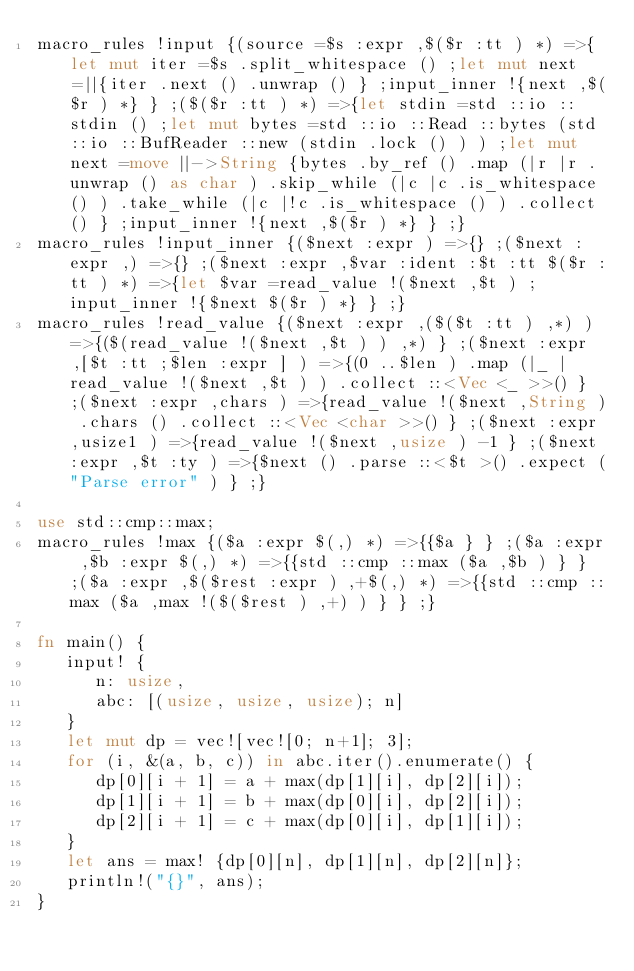Convert code to text. <code><loc_0><loc_0><loc_500><loc_500><_Rust_>macro_rules !input {(source =$s :expr ,$($r :tt ) *) =>{let mut iter =$s .split_whitespace () ;let mut next =||{iter .next () .unwrap () } ;input_inner !{next ,$($r ) *} } ;($($r :tt ) *) =>{let stdin =std ::io ::stdin () ;let mut bytes =std ::io ::Read ::bytes (std ::io ::BufReader ::new (stdin .lock () ) ) ;let mut next =move ||->String {bytes .by_ref () .map (|r |r .unwrap () as char ) .skip_while (|c |c .is_whitespace () ) .take_while (|c |!c .is_whitespace () ) .collect () } ;input_inner !{next ,$($r ) *} } ;}
macro_rules !input_inner {($next :expr ) =>{} ;($next :expr ,) =>{} ;($next :expr ,$var :ident :$t :tt $($r :tt ) *) =>{let $var =read_value !($next ,$t ) ;input_inner !{$next $($r ) *} } ;}
macro_rules !read_value {($next :expr ,($($t :tt ) ,*) ) =>{($(read_value !($next ,$t ) ) ,*) } ;($next :expr ,[$t :tt ;$len :expr ] ) =>{(0 ..$len ) .map (|_ |read_value !($next ,$t ) ) .collect ::<Vec <_ >>() } ;($next :expr ,chars ) =>{read_value !($next ,String ) .chars () .collect ::<Vec <char >>() } ;($next :expr ,usize1 ) =>{read_value !($next ,usize ) -1 } ;($next :expr ,$t :ty ) =>{$next () .parse ::<$t >() .expect ("Parse error" ) } ;}

use std::cmp::max;
macro_rules !max {($a :expr $(,) *) =>{{$a } } ;($a :expr ,$b :expr $(,) *) =>{{std ::cmp ::max ($a ,$b ) } } ;($a :expr ,$($rest :expr ) ,+$(,) *) =>{{std ::cmp ::max ($a ,max !($($rest ) ,+) ) } } ;}

fn main() {
   input! {
      n: usize,
      abc: [(usize, usize, usize); n]
   }
   let mut dp = vec![vec![0; n+1]; 3];
   for (i, &(a, b, c)) in abc.iter().enumerate() {
      dp[0][i + 1] = a + max(dp[1][i], dp[2][i]);
      dp[1][i + 1] = b + max(dp[0][i], dp[2][i]);
      dp[2][i + 1] = c + max(dp[0][i], dp[1][i]);
   }
   let ans = max! {dp[0][n], dp[1][n], dp[2][n]};
   println!("{}", ans);
}
</code> 